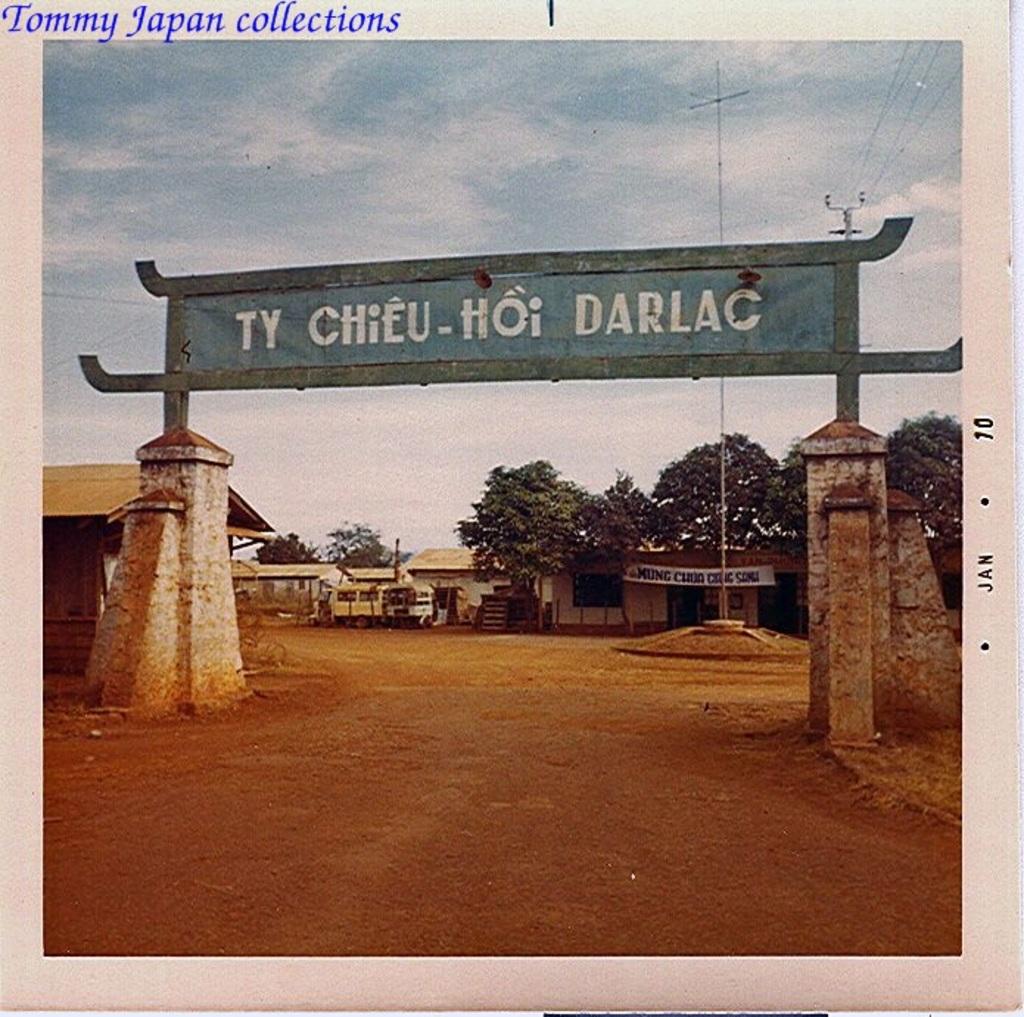What is the last word on the sign?
Your answer should be compact. Darlac. 